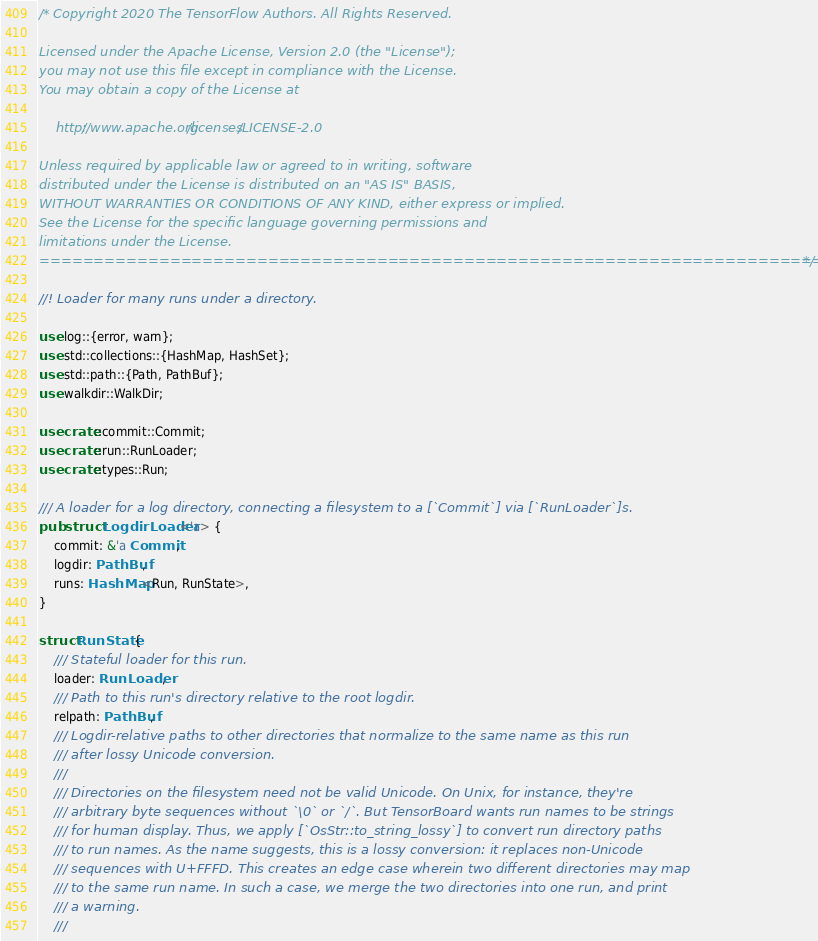Convert code to text. <code><loc_0><loc_0><loc_500><loc_500><_Rust_>/* Copyright 2020 The TensorFlow Authors. All Rights Reserved.

Licensed under the Apache License, Version 2.0 (the "License");
you may not use this file except in compliance with the License.
You may obtain a copy of the License at

    http://www.apache.org/licenses/LICENSE-2.0

Unless required by applicable law or agreed to in writing, software
distributed under the License is distributed on an "AS IS" BASIS,
WITHOUT WARRANTIES OR CONDITIONS OF ANY KIND, either express or implied.
See the License for the specific language governing permissions and
limitations under the License.
==============================================================================*/

//! Loader for many runs under a directory.

use log::{error, warn};
use std::collections::{HashMap, HashSet};
use std::path::{Path, PathBuf};
use walkdir::WalkDir;

use crate::commit::Commit;
use crate::run::RunLoader;
use crate::types::Run;

/// A loader for a log directory, connecting a filesystem to a [`Commit`] via [`RunLoader`]s.
pub struct LogdirLoader<'a> {
    commit: &'a Commit,
    logdir: PathBuf,
    runs: HashMap<Run, RunState>,
}

struct RunState {
    /// Stateful loader for this run.
    loader: RunLoader,
    /// Path to this run's directory relative to the root logdir.
    relpath: PathBuf,
    /// Logdir-relative paths to other directories that normalize to the same name as this run
    /// after lossy Unicode conversion.
    ///
    /// Directories on the filesystem need not be valid Unicode. On Unix, for instance, they're
    /// arbitrary byte sequences without `\0` or `/`. But TensorBoard wants run names to be strings
    /// for human display. Thus, we apply [`OsStr::to_string_lossy`] to convert run directory paths
    /// to run names. As the name suggests, this is a lossy conversion: it replaces non-Unicode
    /// sequences with U+FFFD. This creates an edge case wherein two different directories may map
    /// to the same run name. In such a case, we merge the two directories into one run, and print
    /// a warning.
    ///</code> 